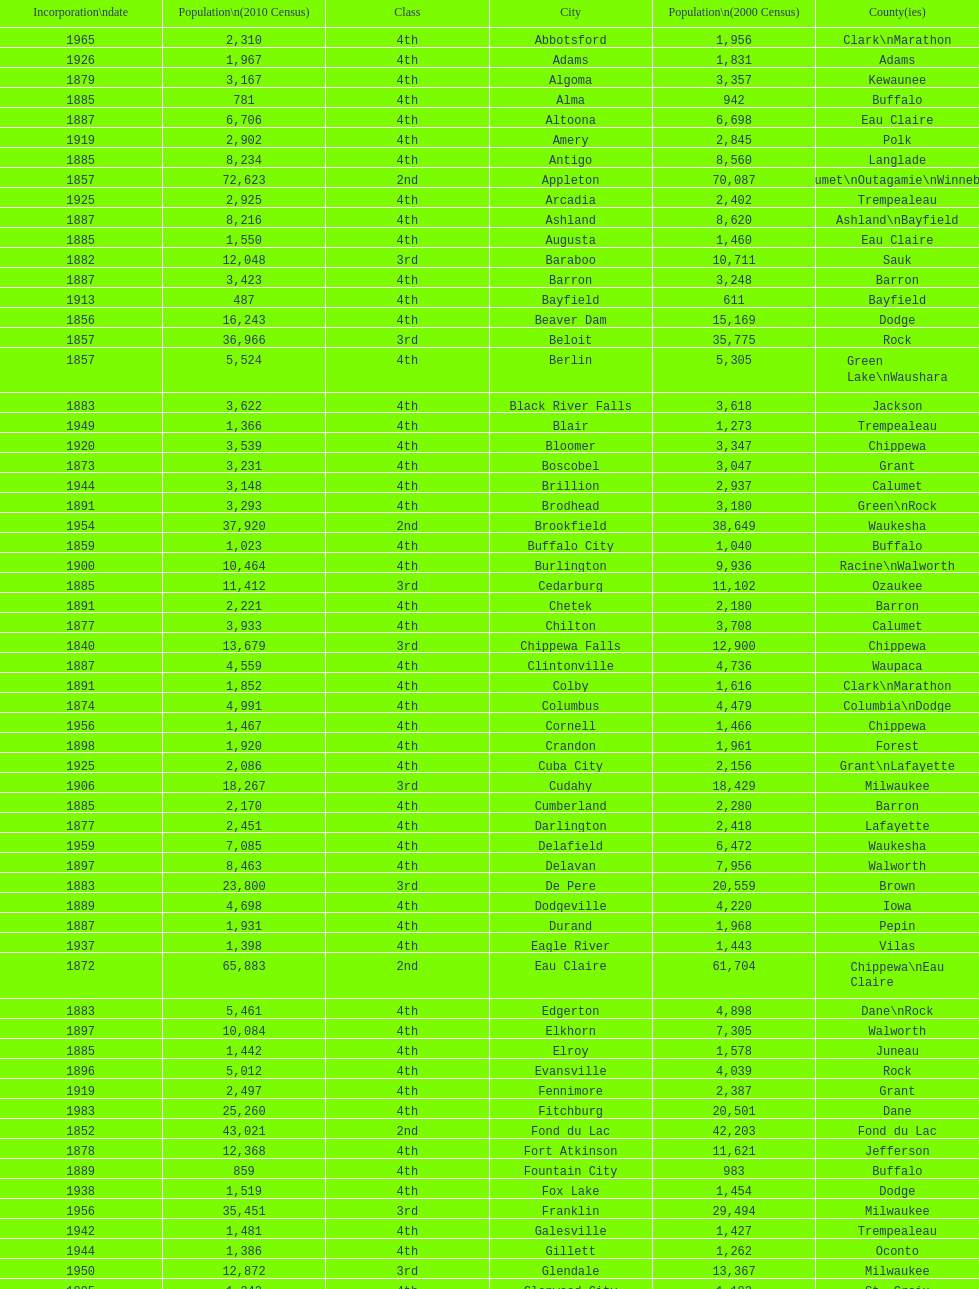What was the first city to be incorporated into wisconsin? Chippewa Falls. 